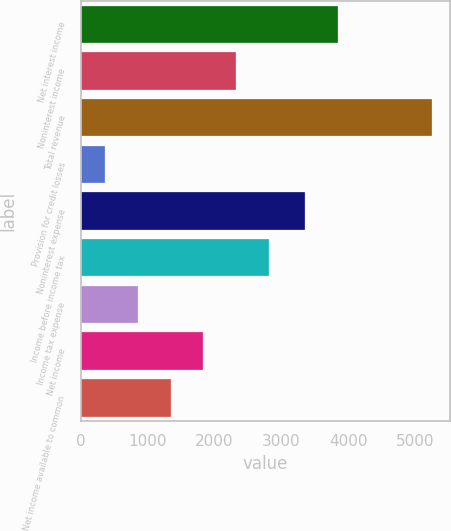Convert chart to OTSL. <chart><loc_0><loc_0><loc_500><loc_500><bar_chart><fcel>Net interest income<fcel>Noninterest income<fcel>Total revenue<fcel>Provision for credit losses<fcel>Noninterest expense<fcel>Income before income tax<fcel>Income tax expense<fcel>Net income<fcel>Net income available to common<nl><fcel>3840.6<fcel>2323.4<fcel>5255<fcel>369<fcel>3352<fcel>2812<fcel>857.6<fcel>1834.8<fcel>1346.2<nl></chart> 